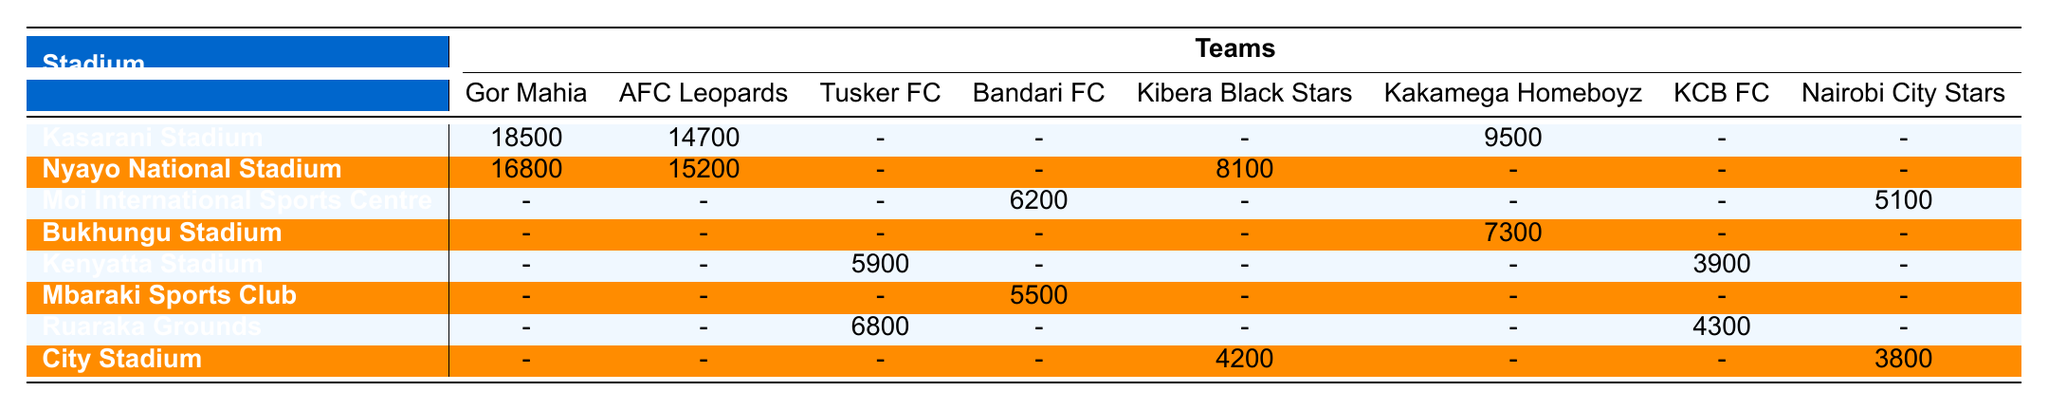What is the highest attendance recorded for Gor Mahia? Gor Mahia has two attendances listed: 18500 at Kasarani Stadium and 16800 at Nyayo National Stadium. The highest among these is 18500.
Answer: 18500 Which team had the lowest attendance in the table? Looking at the attendance figures, Kibera Black Stars had the lowest attendance listed at City Stadium with 4200.
Answer: 4200 How many teams played at Nyayo National Stadium? The teams that played at Nyayo National Stadium are Gor Mahia, AFC Leopards, and Kibera Black Stars. This totals to three teams.
Answer: 3 What is the total attendance for Kibera Black Stars across both their matches? Kibera Black Stars had attendances of 4200 at City Stadium and 8100 at Nyayo National Stadium. Adding these gives 4200 + 8100 = 12300.
Answer: 12300 Did Tusker FC play at Moi International Sports Centre? Upon checking the table, it shows that Tusker FC did not have any attendance recorded at Moi International Sports Centre. Therefore, the answer is no.
Answer: No Which stadium has the highest combined attendance across all teams? To find the highest combined attendance, we sum the attendances for each stadium: Kasarani (18500 + 14700 + 9500) = 42700, Nyayo (16800 + 15200 + 8100) = 40100, Moi (6200 + 5100) = 11300, Bukhungu (7300), Kenyatta (5900 + 3900), Mbaraki (5500), Ruaraka (6800 + 4300), City (4200 + 3800) = 8000. The highest combined attendance is at Kasarani Stadium with 42700.
Answer: Kasarani Stadium Which stadium had more matches played, Nyayo National Stadium or City Stadium? Nyayo National Stadium hosted three matches (with Gor Mahia, AFC Leopards, and Kibera Black Stars), while City Stadium hosted two (with Kibera Black Stars and Nairobi City Stars). Therefore, Nyayo National Stadium had more matches than City Stadium.
Answer: Yes What is the average attendance for the teams that played at Bukhungu Stadium? Only Kakamega Homeboyz played at Bukhungu Stadium with an attendance of 7300. Since there's only one team, the average is simply 7300, which is the value itself.
Answer: 7300 Did any team have attendances recorded for both Kasarani Stadium and Nyayo National Stadium? Yes, Gor Mahia played at both Kasarani Stadium (18500) and Nyayo National Stadium (16800), so they had attendances recorded at both venues.
Answer: Yes What is the difference in attendance between the highest and lowest attendance recorded for KCB FC? KCB FC had an attendance of 3900 at Kenyatta Stadium and 4300 at Ruaraka Grounds. The difference is 4300 - 3900 = 400.
Answer: 400 What is the average attendance for all matches at Kasarani Stadium? Matches at Kasarani Stadium had attendances of 18500 (Gor Mahia), 14700 (AFC Leopards), and 9500 (Kakamega Homeboyz). The total is 18500 + 14700 + 9500 = 42700. There are three matches, so the average is 42700 / 3 ≈ 14233.33.
Answer: 14233.33 